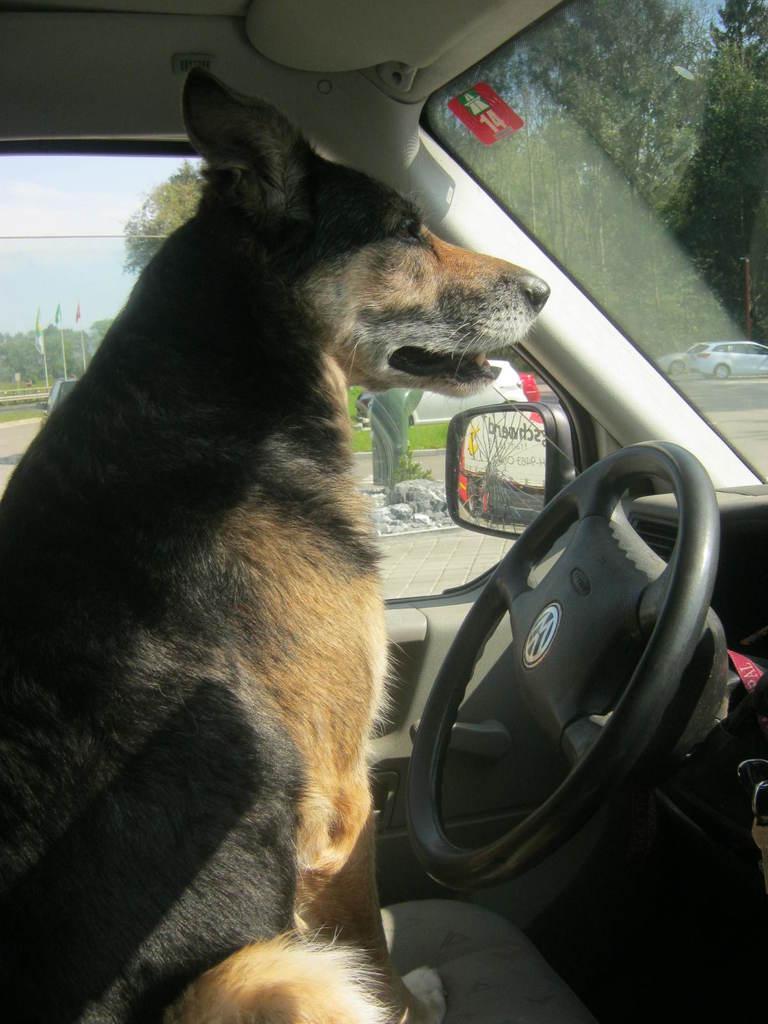Can you describe this image briefly? In this image i can see a dog in a car. 